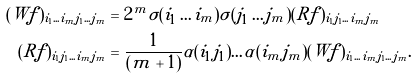<formula> <loc_0><loc_0><loc_500><loc_500>( W f ) _ { i _ { 1 } \dots i _ { m } j _ { 1 } \dots j _ { m } } & = 2 ^ { m } \sigma ( i _ { 1 } \dots i _ { m } ) \sigma ( j _ { 1 } \dots j _ { m } ) ( R f ) _ { i _ { 1 } j _ { 1 } \dots i _ { m } j _ { m } } \\ ( R f ) _ { i _ { 1 } j _ { 1 } \dots i _ { m } j _ { m } } & = \frac { 1 } { ( m + 1 ) } \alpha ( i _ { 1 } j _ { 1 } ) \dots \alpha ( i _ { m } j _ { m } ) ( W f ) _ { i _ { 1 } \dots i _ { m } j _ { 1 } \dots j _ { m } } .</formula> 